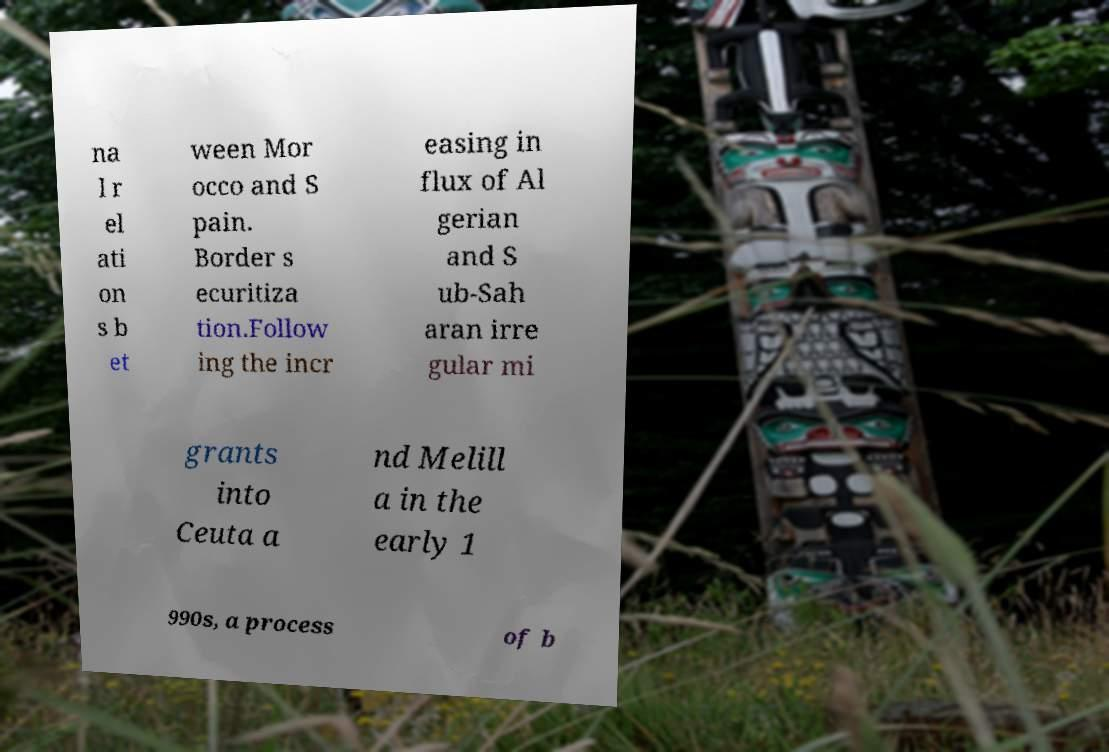I need the written content from this picture converted into text. Can you do that? na l r el ati on s b et ween Mor occo and S pain. Border s ecuritiza tion.Follow ing the incr easing in flux of Al gerian and S ub-Sah aran irre gular mi grants into Ceuta a nd Melill a in the early 1 990s, a process of b 